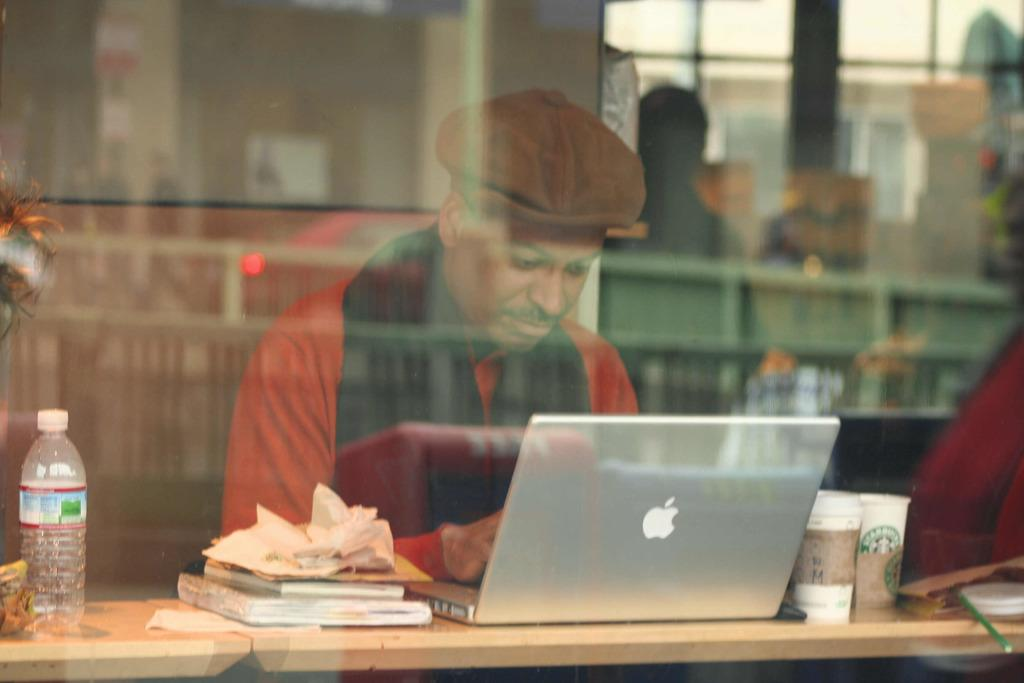What is the man in the image doing? The man is sitting on a chair in the image. What is in front of the man? There is a table in front of the man. What electronic device is on the table? A laptop is present on the table. What else can be seen on the table? Glasses and books are on the table, along with other objects. What type of engine is visible in the image? There is no engine present in the image. Can you see a flame coming from any of the objects on the table? There is no flame visible in the image. 